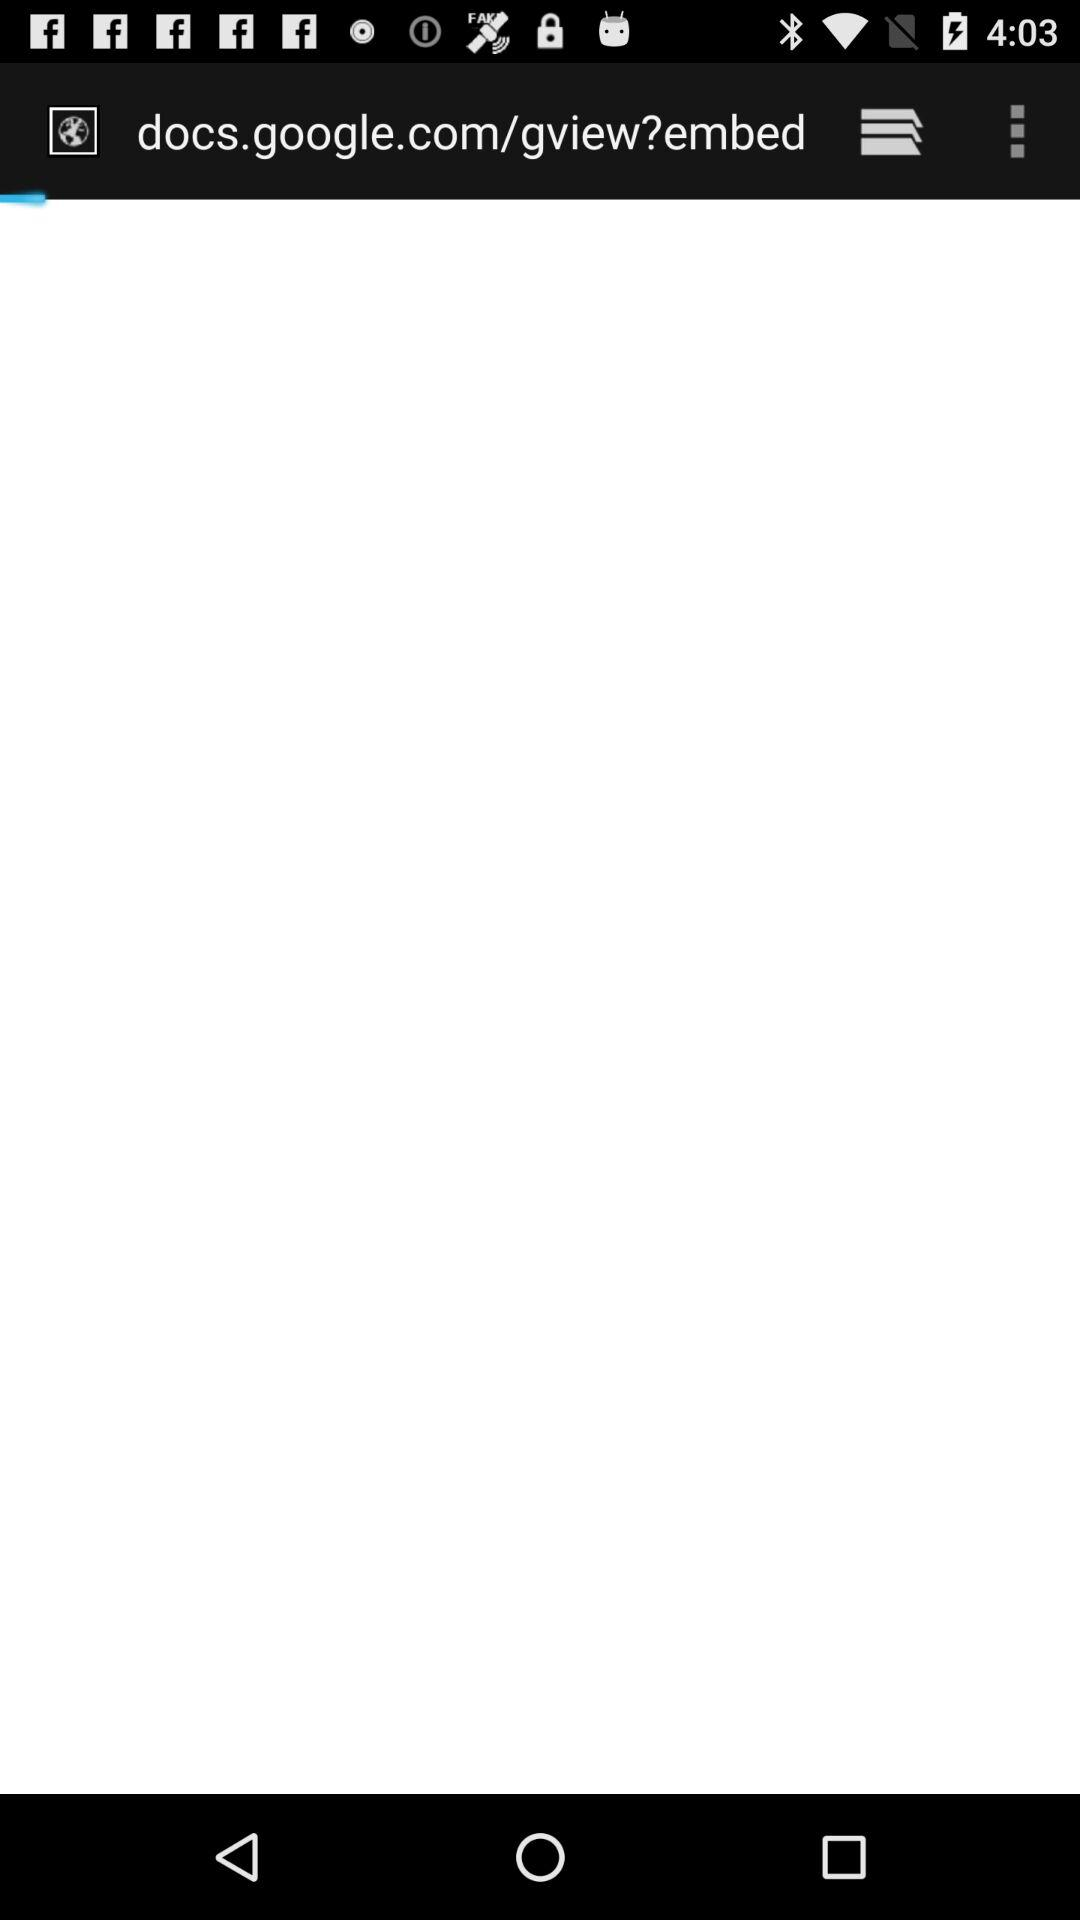What is the login ID name? The login ID name is John. 